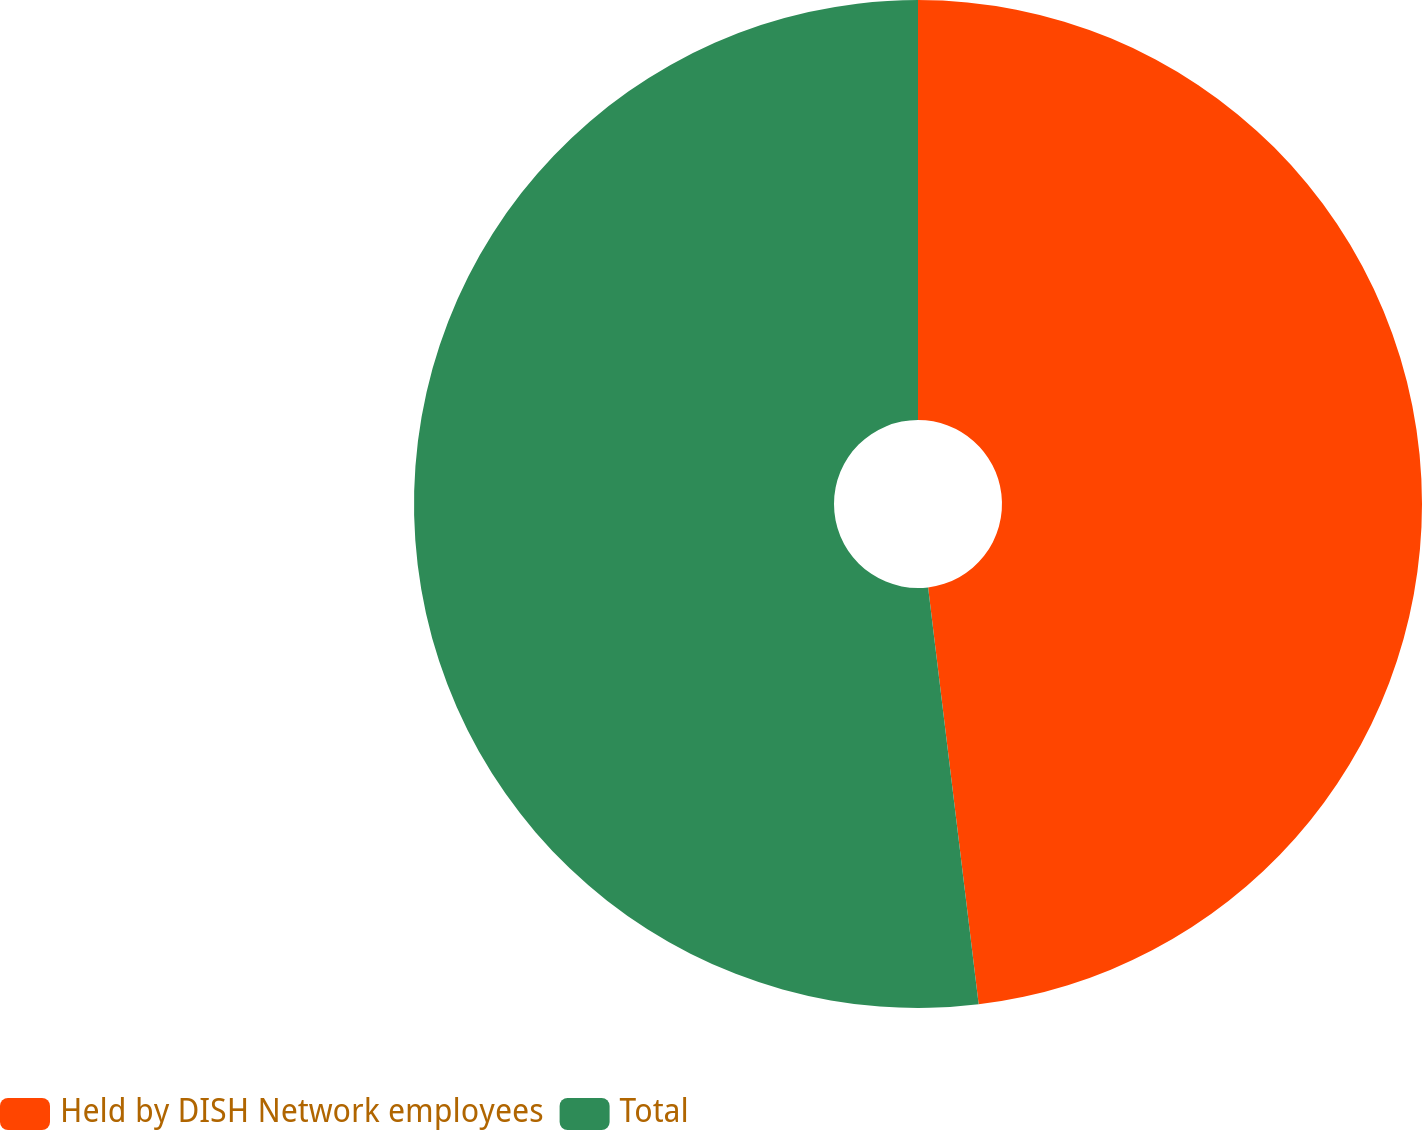Convert chart to OTSL. <chart><loc_0><loc_0><loc_500><loc_500><pie_chart><fcel>Held by DISH Network employees<fcel>Total<nl><fcel>48.08%<fcel>51.92%<nl></chart> 